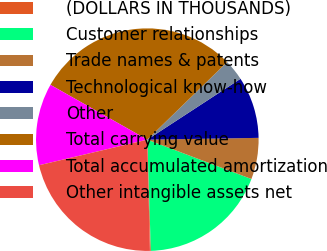<chart> <loc_0><loc_0><loc_500><loc_500><pie_chart><fcel>(DOLLARS IN THOUSANDS)<fcel>Customer relationships<fcel>Trade names & patents<fcel>Technological know-how<fcel>Other<fcel>Total carrying value<fcel>Total accumulated amortization<fcel>Other intangible assets net<nl><fcel>0.13%<fcel>18.74%<fcel>6.01%<fcel>8.95%<fcel>3.07%<fcel>29.53%<fcel>11.89%<fcel>21.68%<nl></chart> 